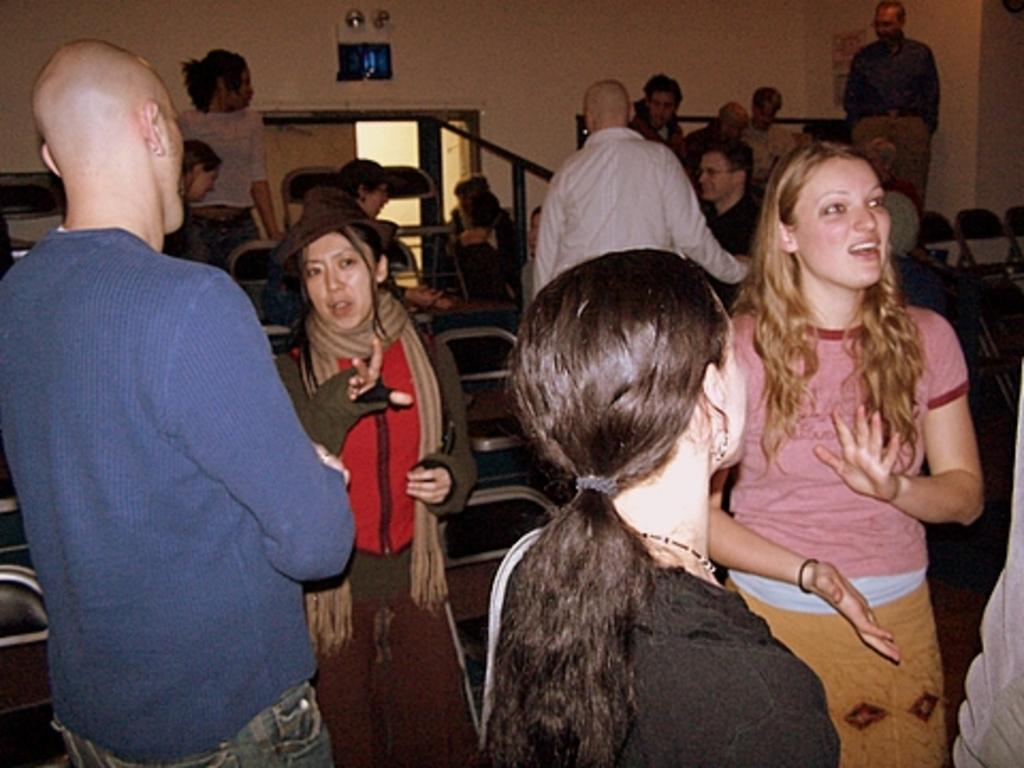How many people are in the image? There is a group of people in the image. What are two women doing in the image? Two women are talking with others in the image. What can be seen in the background of the image? There are chairs, a wall, rods, a door, and a poster in the background of the image. What type of bottle is being passed around by the group in the image? There is no bottle present in the image; the group is talking with each other. 